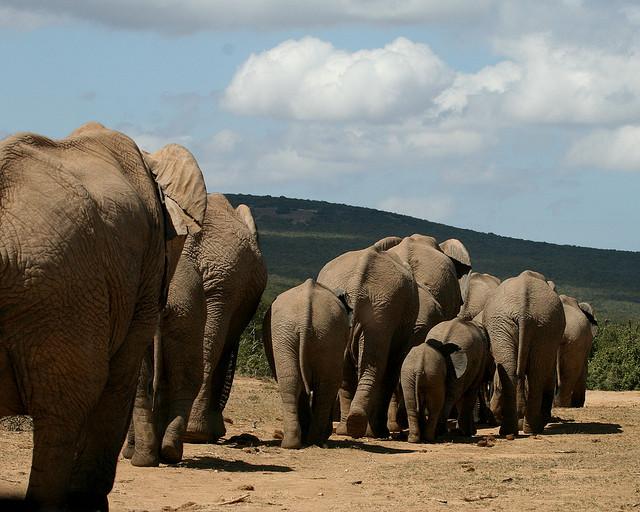What's the elephant looking at?
Give a very brief answer. Trees. Are the elephants in their natural habitat?
Give a very brief answer. Yes. What part of the elephants are touching?
Answer briefly. Sides. Are the elephants walking away from the photographer?
Be succinct. Yes. What color are the elephants?
Keep it brief. Gray. Was this photo taken at a zoo?
Give a very brief answer. No. 